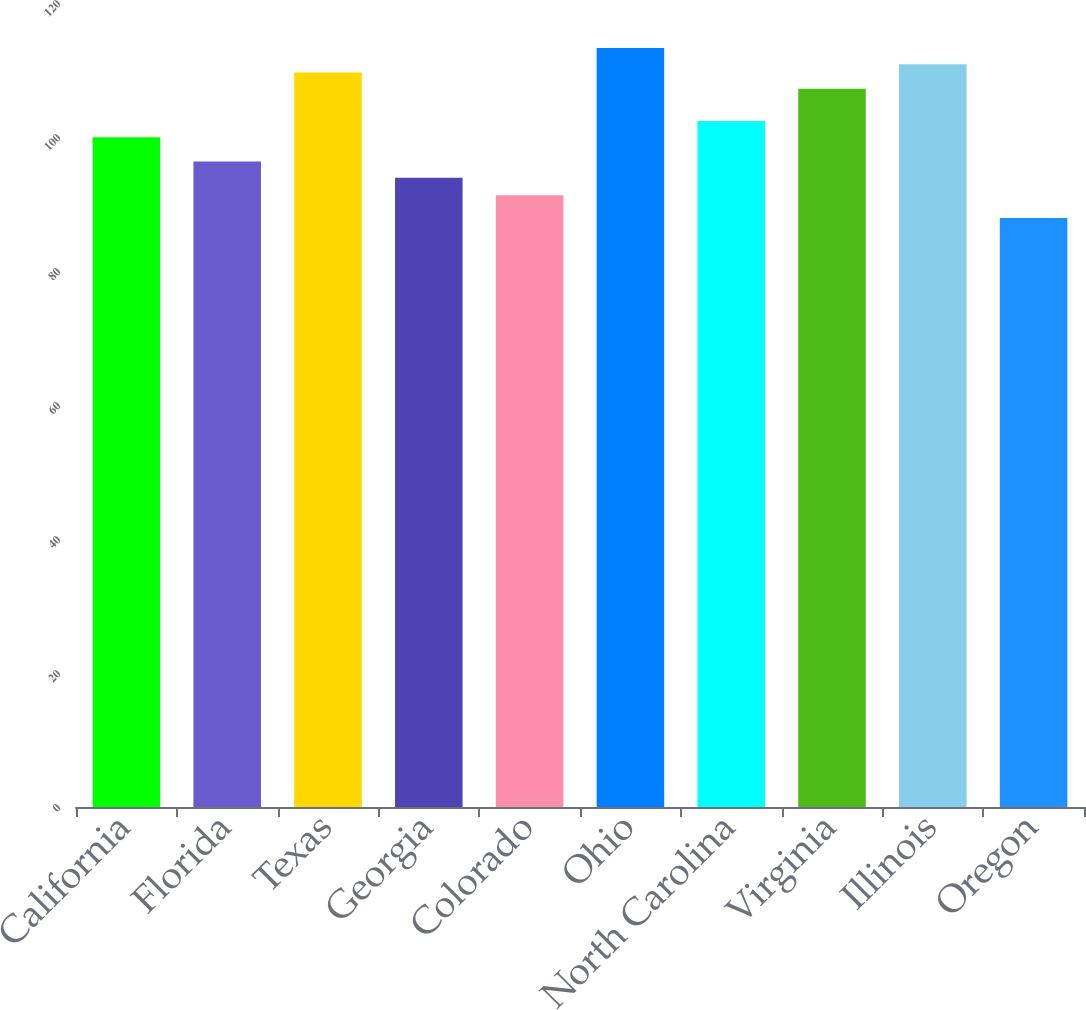Convert chart to OTSL. <chart><loc_0><loc_0><loc_500><loc_500><bar_chart><fcel>California<fcel>Florida<fcel>Texas<fcel>Georgia<fcel>Colorado<fcel>Ohio<fcel>North Carolina<fcel>Virginia<fcel>Illinois<fcel>Oregon<nl><fcel>99.96<fcel>96.33<fcel>109.64<fcel>93.91<fcel>91.31<fcel>113.27<fcel>102.38<fcel>107.22<fcel>110.85<fcel>87.9<nl></chart> 